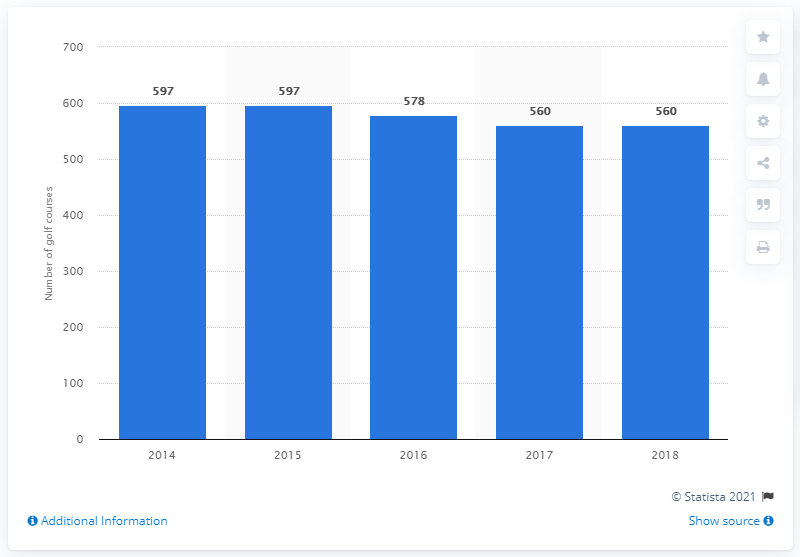Point out several critical features in this image. In 2018, there were 560 golf courses in Scotland. 